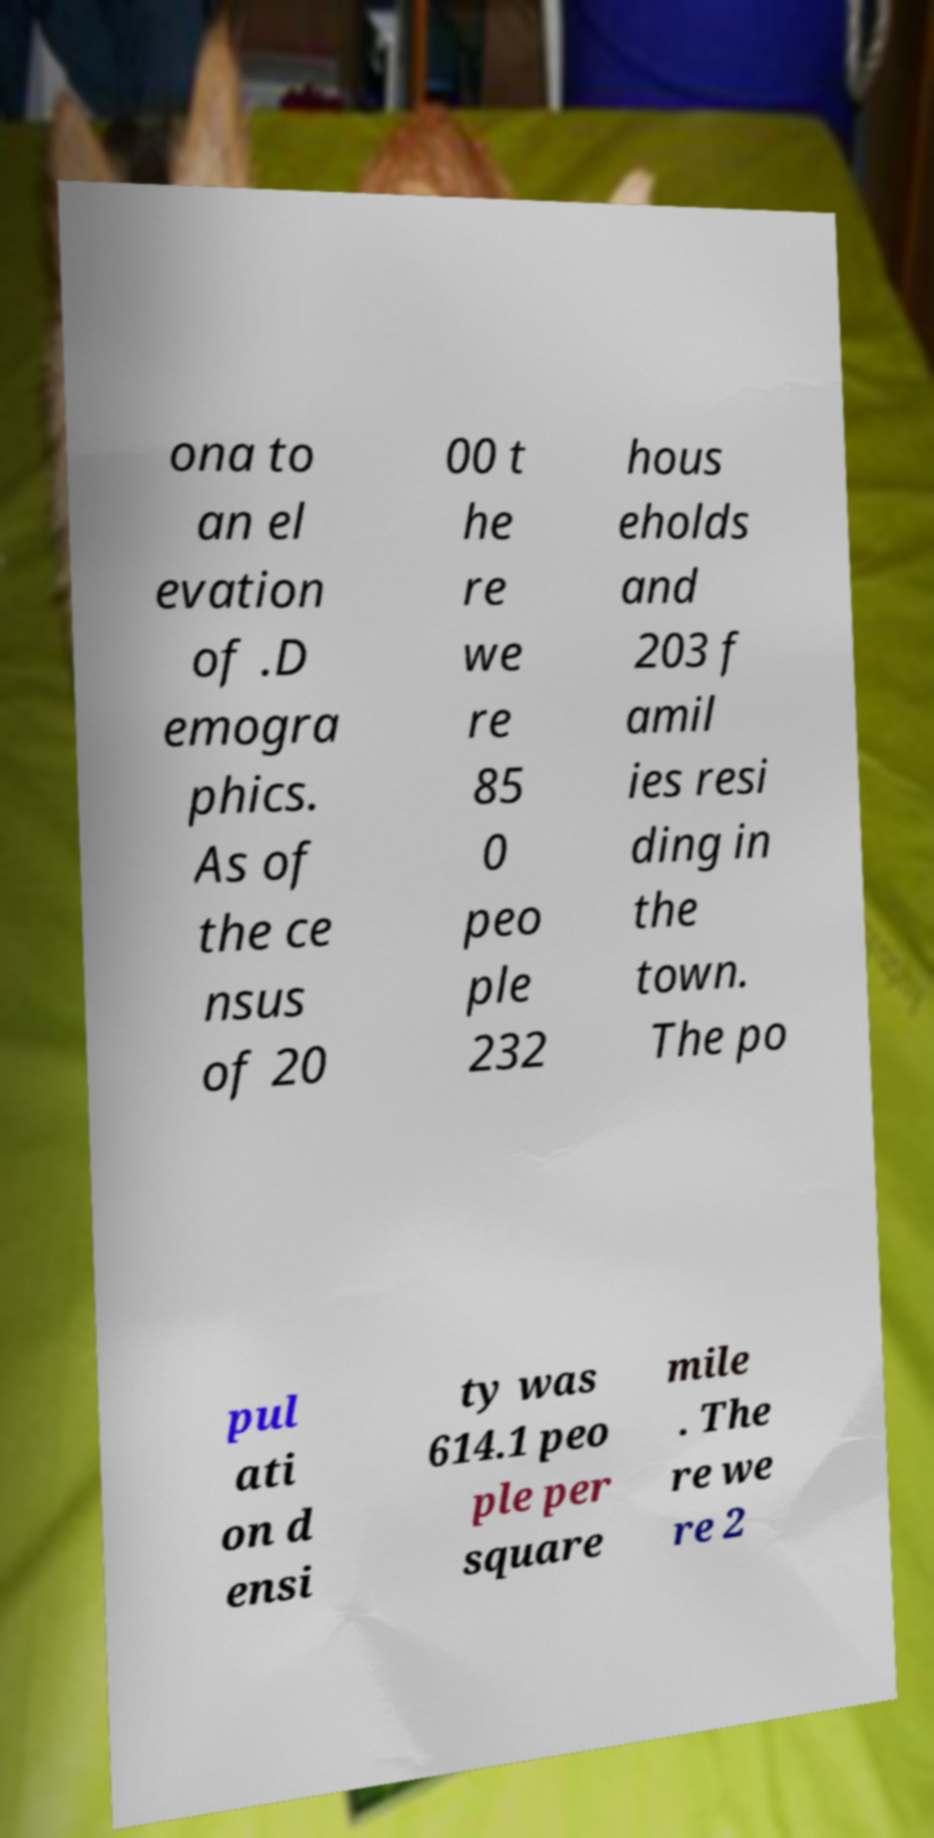I need the written content from this picture converted into text. Can you do that? ona to an el evation of .D emogra phics. As of the ce nsus of 20 00 t he re we re 85 0 peo ple 232 hous eholds and 203 f amil ies resi ding in the town. The po pul ati on d ensi ty was 614.1 peo ple per square mile . The re we re 2 